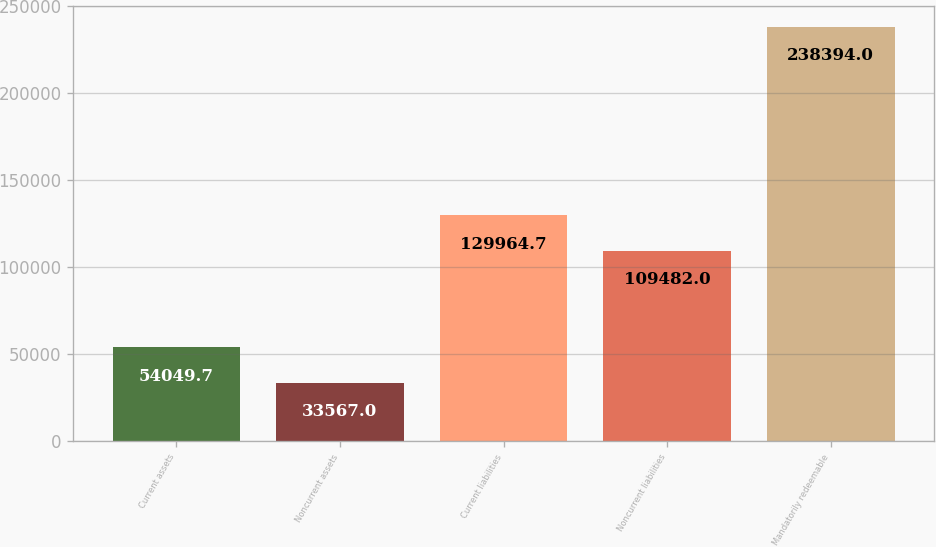Convert chart. <chart><loc_0><loc_0><loc_500><loc_500><bar_chart><fcel>Current assets<fcel>Noncurrent assets<fcel>Current liabilities<fcel>Noncurrent liabilities<fcel>Mandatorily redeemable<nl><fcel>54049.7<fcel>33567<fcel>129965<fcel>109482<fcel>238394<nl></chart> 